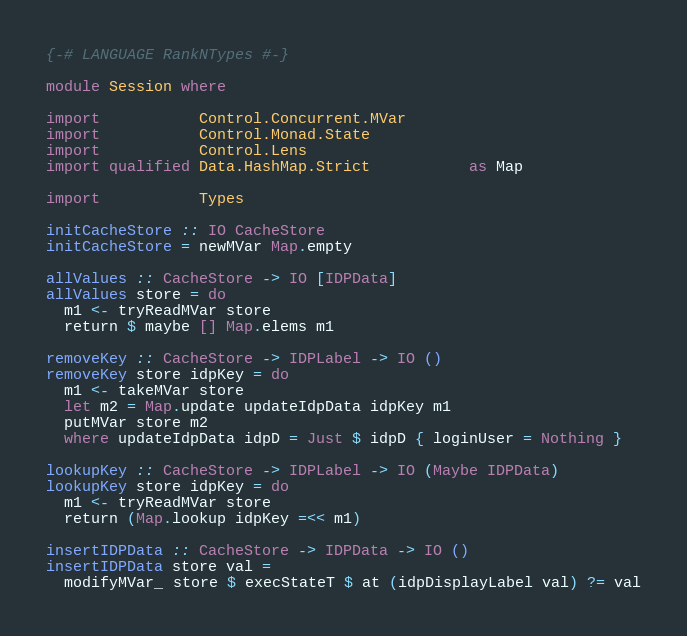<code> <loc_0><loc_0><loc_500><loc_500><_Haskell_>{-# LANGUAGE RankNTypes #-}

module Session where

import           Control.Concurrent.MVar
import           Control.Monad.State
import           Control.Lens
import qualified Data.HashMap.Strict           as Map

import           Types

initCacheStore :: IO CacheStore
initCacheStore = newMVar Map.empty

allValues :: CacheStore -> IO [IDPData]
allValues store = do
  m1 <- tryReadMVar store
  return $ maybe [] Map.elems m1

removeKey :: CacheStore -> IDPLabel -> IO ()
removeKey store idpKey = do
  m1 <- takeMVar store
  let m2 = Map.update updateIdpData idpKey m1
  putMVar store m2
  where updateIdpData idpD = Just $ idpD { loginUser = Nothing }

lookupKey :: CacheStore -> IDPLabel -> IO (Maybe IDPData)
lookupKey store idpKey = do
  m1 <- tryReadMVar store
  return (Map.lookup idpKey =<< m1)

insertIDPData :: CacheStore -> IDPData -> IO ()
insertIDPData store val =
  modifyMVar_ store $ execStateT $ at (idpDisplayLabel val) ?= val
</code> 